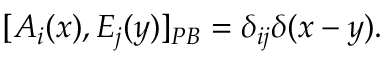Convert formula to latex. <formula><loc_0><loc_0><loc_500><loc_500>[ A _ { i } ( x ) , E _ { j } ( y ) ] _ { P B } = \delta _ { i j } \delta ( x - y ) .</formula> 